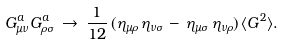<formula> <loc_0><loc_0><loc_500><loc_500>G _ { \mu \nu } ^ { a } G _ { \rho \sigma } ^ { a } \, \rightarrow \, \frac { 1 } { 1 2 } \, ( \eta _ { \mu \rho } \, \eta _ { \nu \sigma } \, - \, \eta _ { \mu \sigma } \, \eta _ { \nu \rho } ) \, \langle G ^ { 2 } \rangle .</formula> 